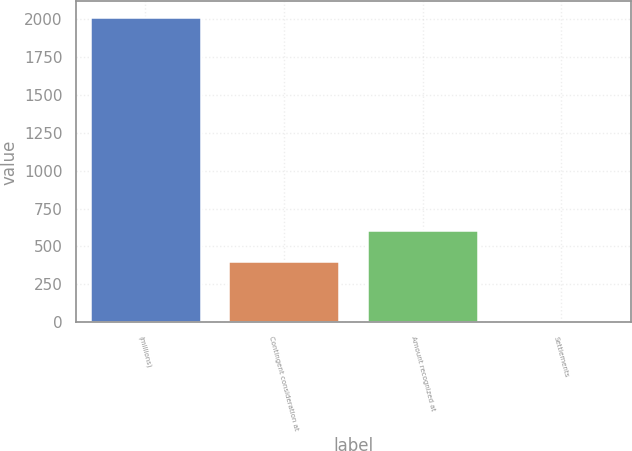<chart> <loc_0><loc_0><loc_500><loc_500><bar_chart><fcel>(millions)<fcel>Contingent consideration at<fcel>Amount recognized at<fcel>Settlements<nl><fcel>2015<fcel>403.8<fcel>605.2<fcel>1<nl></chart> 